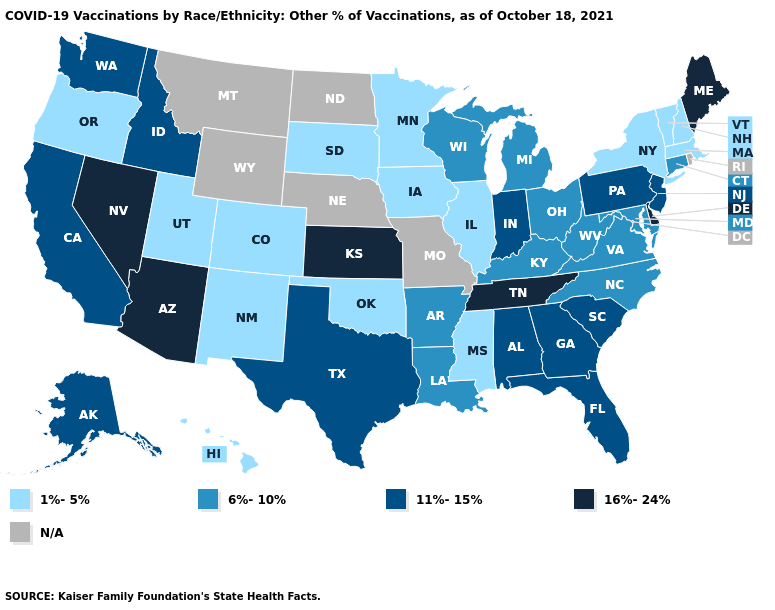How many symbols are there in the legend?
Quick response, please. 5. Which states have the lowest value in the South?
Answer briefly. Mississippi, Oklahoma. What is the highest value in states that border Mississippi?
Be succinct. 16%-24%. Does Tennessee have the highest value in the South?
Write a very short answer. Yes. Among the states that border South Carolina , does North Carolina have the highest value?
Short answer required. No. What is the value of New Mexico?
Concise answer only. 1%-5%. What is the lowest value in the USA?
Quick response, please. 1%-5%. Does Michigan have the highest value in the MidWest?
Answer briefly. No. What is the highest value in the USA?
Quick response, please. 16%-24%. Which states have the lowest value in the USA?
Be succinct. Colorado, Hawaii, Illinois, Iowa, Massachusetts, Minnesota, Mississippi, New Hampshire, New Mexico, New York, Oklahoma, Oregon, South Dakota, Utah, Vermont. Name the states that have a value in the range 11%-15%?
Write a very short answer. Alabama, Alaska, California, Florida, Georgia, Idaho, Indiana, New Jersey, Pennsylvania, South Carolina, Texas, Washington. Name the states that have a value in the range 6%-10%?
Write a very short answer. Arkansas, Connecticut, Kentucky, Louisiana, Maryland, Michigan, North Carolina, Ohio, Virginia, West Virginia, Wisconsin. Is the legend a continuous bar?
Give a very brief answer. No. Name the states that have a value in the range 6%-10%?
Keep it brief. Arkansas, Connecticut, Kentucky, Louisiana, Maryland, Michigan, North Carolina, Ohio, Virginia, West Virginia, Wisconsin. 